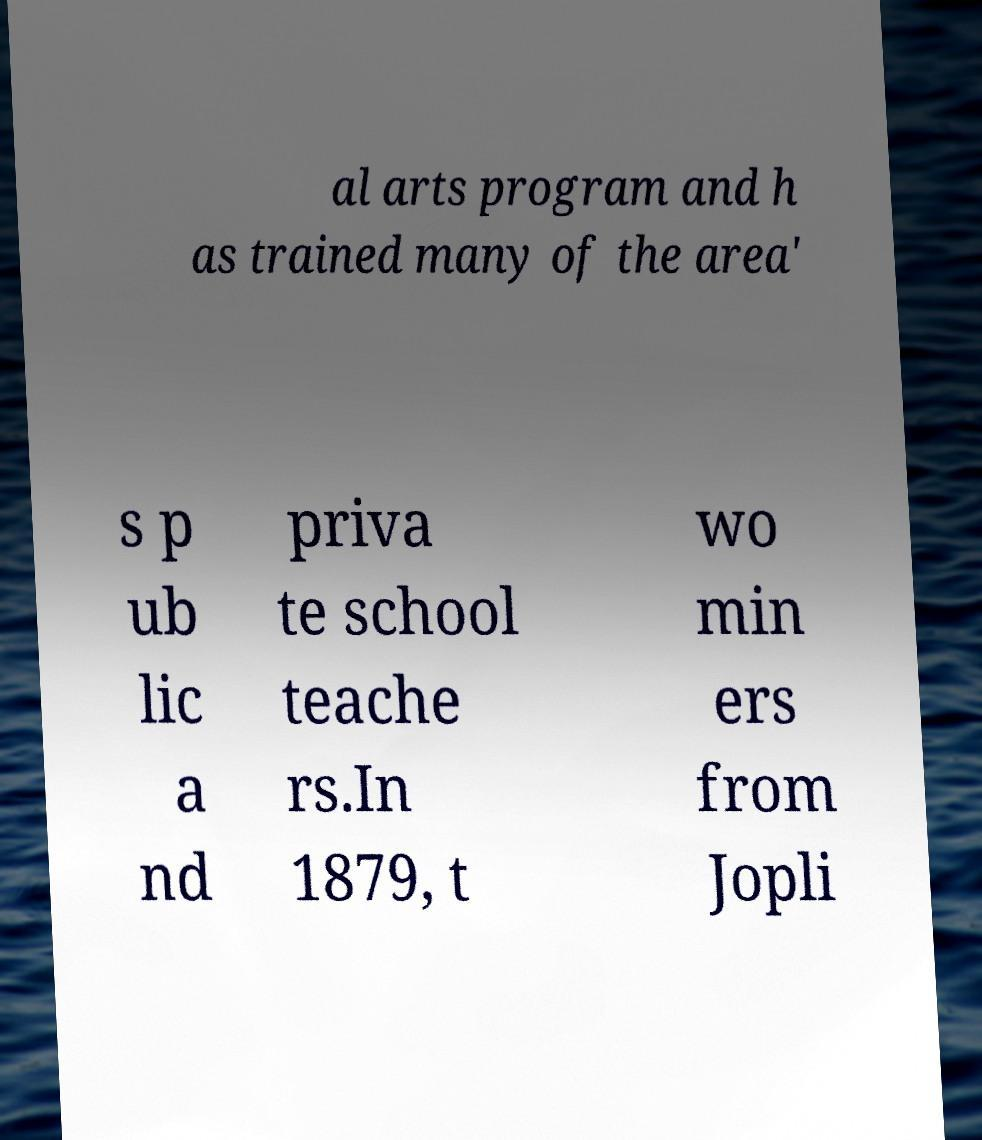I need the written content from this picture converted into text. Can you do that? al arts program and h as trained many of the area' s p ub lic a nd priva te school teache rs.In 1879, t wo min ers from Jopli 